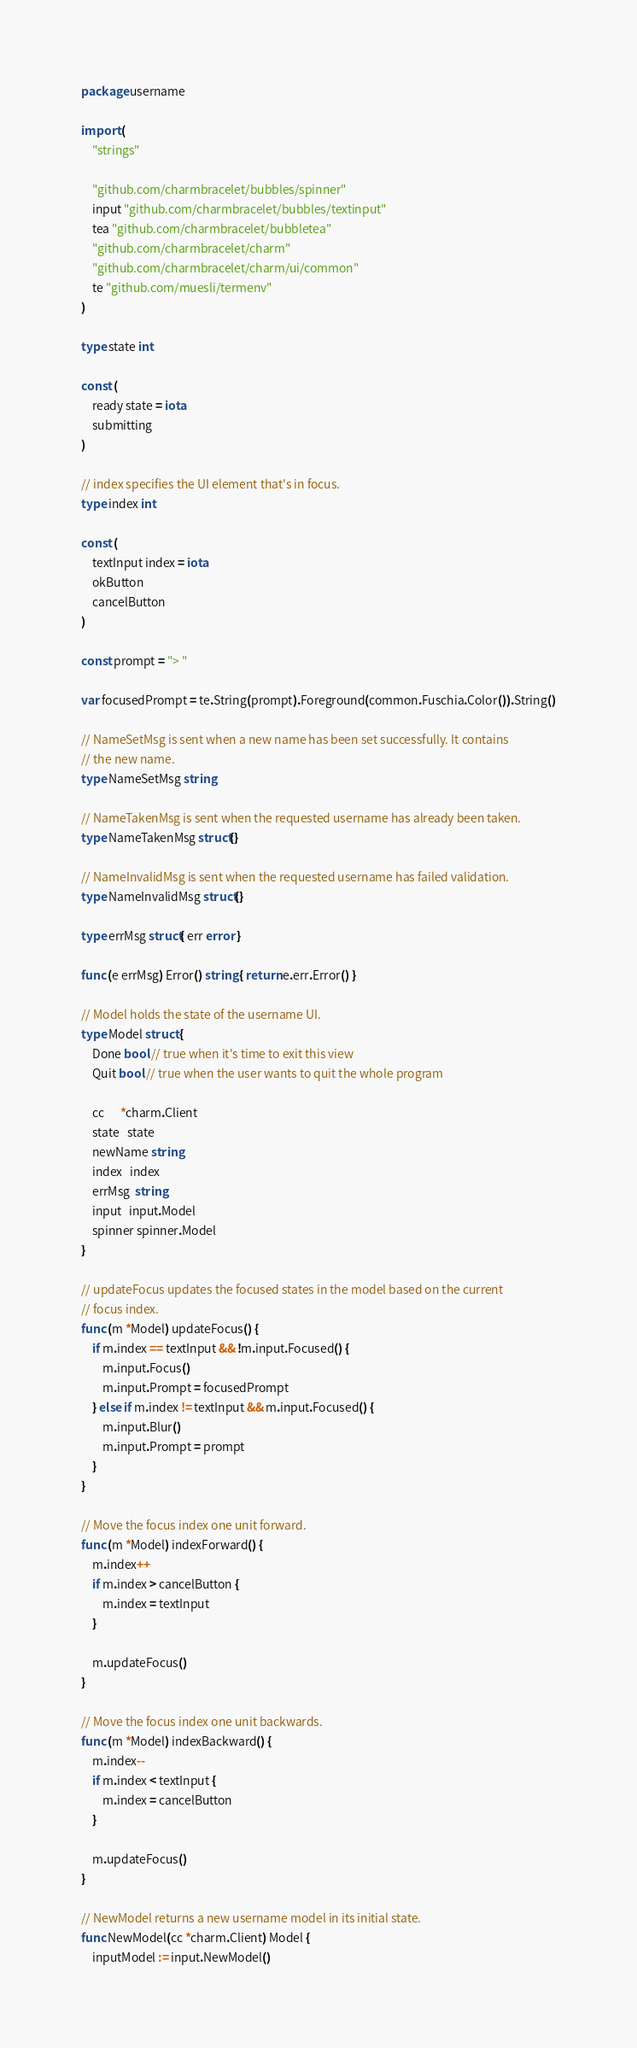Convert code to text. <code><loc_0><loc_0><loc_500><loc_500><_Go_>package username

import (
	"strings"

	"github.com/charmbracelet/bubbles/spinner"
	input "github.com/charmbracelet/bubbles/textinput"
	tea "github.com/charmbracelet/bubbletea"
	"github.com/charmbracelet/charm"
	"github.com/charmbracelet/charm/ui/common"
	te "github.com/muesli/termenv"
)

type state int

const (
	ready state = iota
	submitting
)

// index specifies the UI element that's in focus.
type index int

const (
	textInput index = iota
	okButton
	cancelButton
)

const prompt = "> "

var focusedPrompt = te.String(prompt).Foreground(common.Fuschia.Color()).String()

// NameSetMsg is sent when a new name has been set successfully. It contains
// the new name.
type NameSetMsg string

// NameTakenMsg is sent when the requested username has already been taken.
type NameTakenMsg struct{}

// NameInvalidMsg is sent when the requested username has failed validation.
type NameInvalidMsg struct{}

type errMsg struct{ err error }

func (e errMsg) Error() string { return e.err.Error() }

// Model holds the state of the username UI.
type Model struct {
	Done bool // true when it's time to exit this view
	Quit bool // true when the user wants to quit the whole program

	cc      *charm.Client
	state   state
	newName string
	index   index
	errMsg  string
	input   input.Model
	spinner spinner.Model
}

// updateFocus updates the focused states in the model based on the current
// focus index.
func (m *Model) updateFocus() {
	if m.index == textInput && !m.input.Focused() {
		m.input.Focus()
		m.input.Prompt = focusedPrompt
	} else if m.index != textInput && m.input.Focused() {
		m.input.Blur()
		m.input.Prompt = prompt
	}
}

// Move the focus index one unit forward.
func (m *Model) indexForward() {
	m.index++
	if m.index > cancelButton {
		m.index = textInput
	}

	m.updateFocus()
}

// Move the focus index one unit backwards.
func (m *Model) indexBackward() {
	m.index--
	if m.index < textInput {
		m.index = cancelButton
	}

	m.updateFocus()
}

// NewModel returns a new username model in its initial state.
func NewModel(cc *charm.Client) Model {
	inputModel := input.NewModel()</code> 